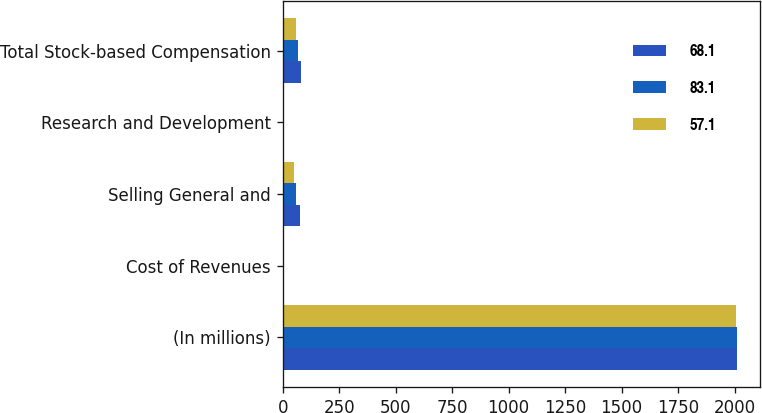<chart> <loc_0><loc_0><loc_500><loc_500><stacked_bar_chart><ecel><fcel>(In millions)<fcel>Cost of Revenues<fcel>Selling General and<fcel>Research and Development<fcel>Total Stock-based Compensation<nl><fcel>68.1<fcel>2010<fcel>6<fcel>75.2<fcel>1.9<fcel>83.1<nl><fcel>83.1<fcel>2009<fcel>6.2<fcel>59.8<fcel>2.1<fcel>68.1<nl><fcel>57.1<fcel>2008<fcel>4.2<fcel>51.3<fcel>1.6<fcel>57.1<nl></chart> 